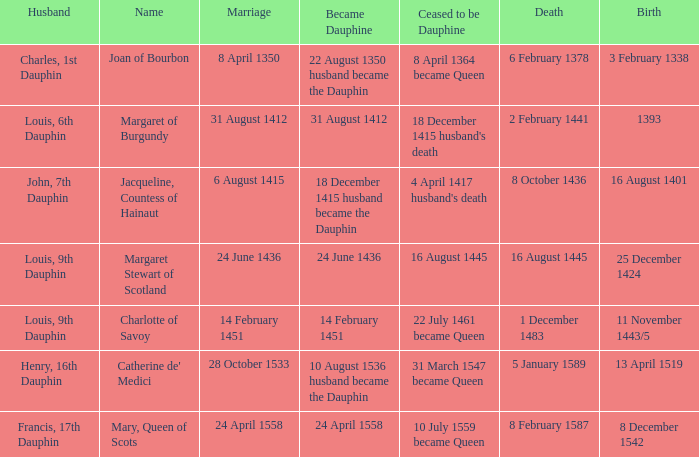When was became dauphine when birth is 1393? 31 August 1412. 